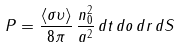Convert formula to latex. <formula><loc_0><loc_0><loc_500><loc_500>P = \frac { \langle \sigma \upsilon \rangle } { 8 \pi } \, \frac { n _ { 0 } ^ { 2 } } { a ^ { 2 } } \, d t \, d o \, d r \, d S</formula> 